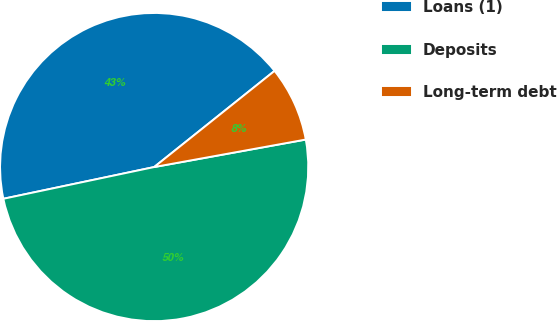Convert chart to OTSL. <chart><loc_0><loc_0><loc_500><loc_500><pie_chart><fcel>Loans (1)<fcel>Deposits<fcel>Long-term debt<nl><fcel>42.57%<fcel>49.55%<fcel>7.87%<nl></chart> 